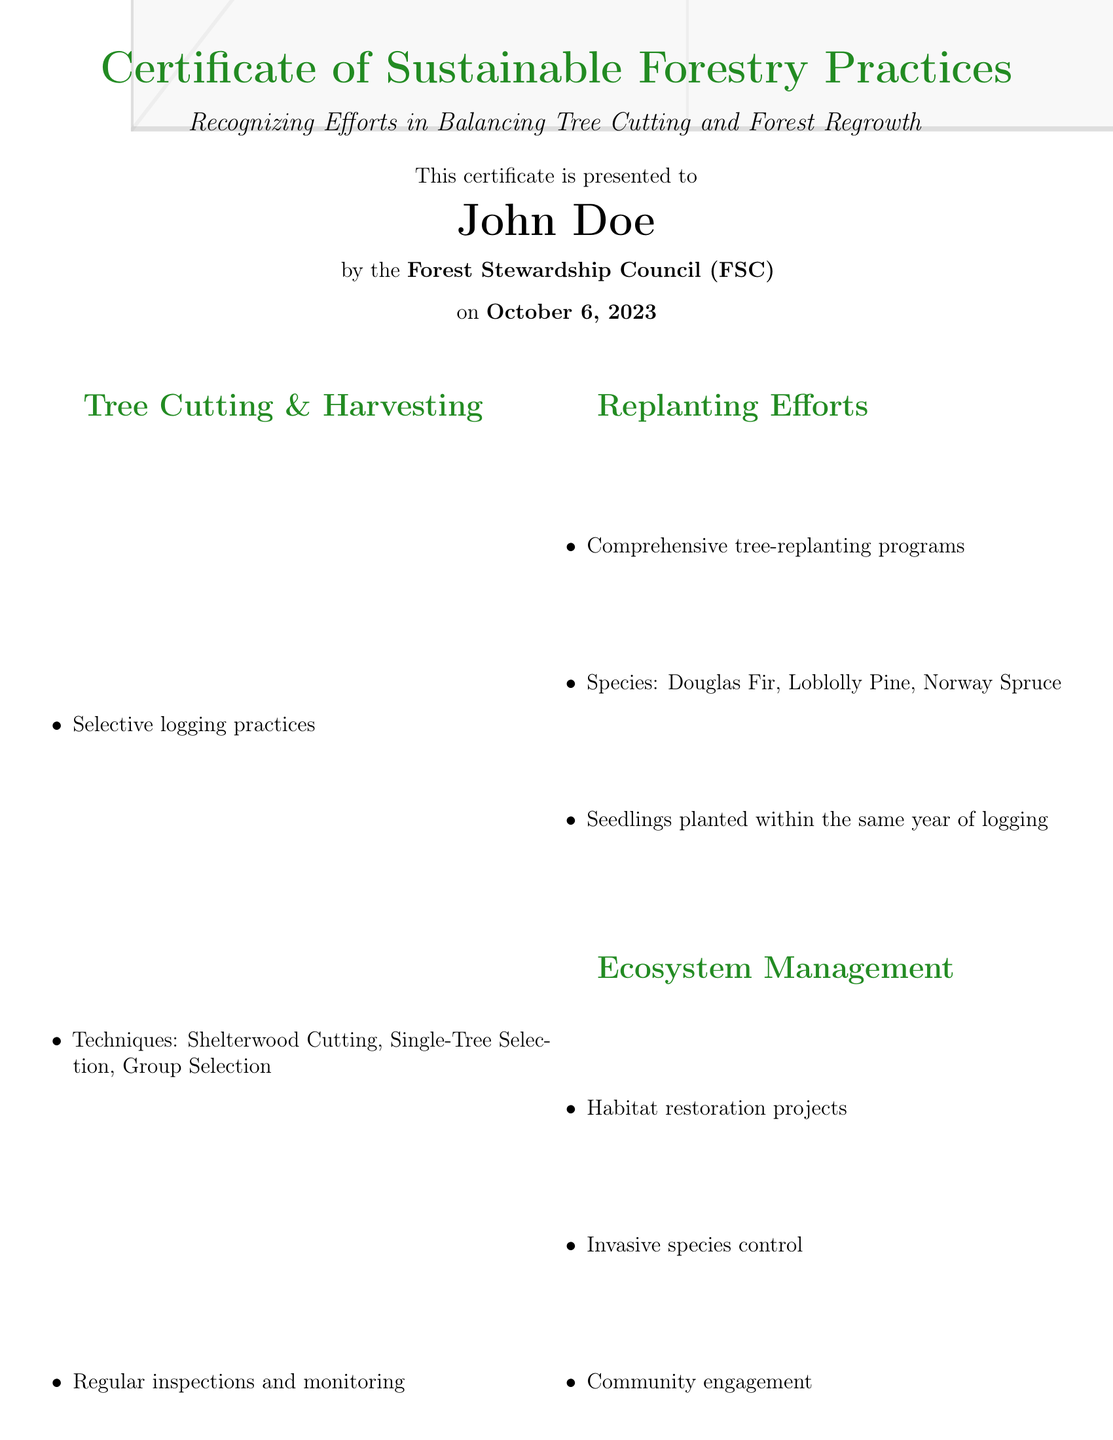What is the title of the certificate? The title indicates the subject of the document, which is "Certificate of Sustainable Forestry Practices."
Answer: Certificate of Sustainable Forestry Practices Who is the certificate presented to? The document specifies the recipient of the certificate directly as "John Doe."
Answer: John Doe What is the date of the certificate issuance? The issuance date is clearly mentioned in the document as "October 6, 2023."
Answer: October 6, 2023 What type of environmental management system is mentioned? The document states the certification as "ISO 14001 Environmental Management System."
Answer: ISO 14001 Environmental Management System What species are included in the replanting efforts? The document lists the species as "Douglas Fir, Loblolly Pine, Norway Spruce."
Answer: Douglas Fir, Loblolly Pine, Norway Spruce What organization issued the certificate? The organization presenting the certificate is named as "Forest Stewardship Council (FSC)."
Answer: Forest Stewardship Council (FSC) What practices are used in tree cutting? The document specifies the practices as "Selective logging practices."
Answer: Selective logging practices Who signed the certificate? The signature section indicates that it was signed by "Jane Smith."
Answer: Jane Smith 